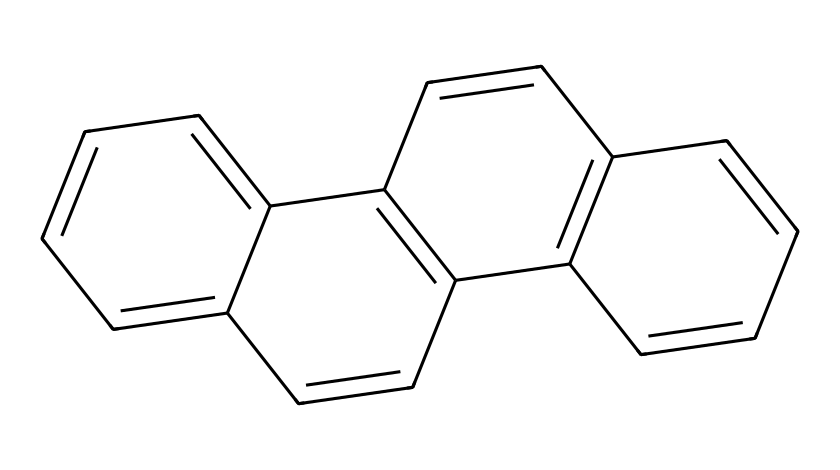What is the name of this chemical? The SMILES representation corresponds to a polycyclic aromatic hydrocarbon known as chrysene, which is characterized by its fused ring structure.
Answer: chrysene How many carbon atoms are in this molecule? By analyzing the structure represented in the SMILES, we can count a total of 18 carbon atoms in the fused ring systems.
Answer: 18 How many hydrogen atoms does this chemical have? Each carbon in this polycyclic aromatic structure is bonded to either another carbon or a hydrogen atom. Given the rings and carbon count, there are 12 hydrogen atoms.
Answer: 12 Is this molecule considered a carcinogen? Polycyclic aromatic hydrocarbons, including chrysene, are known for their potential carcinogenic properties, due to how they interact with biological systems.
Answer: yes What type of hydrocarbons does this structure represent? The structure consists of multiple fused benzene rings, classifying it as a polycyclic aromatic hydrocarbon (PAH).
Answer: polycyclic aromatic hydrocarbon How many rings are fused together in this structure? Looking at the molecular arrangement, it is clear that there are four distinct benzene rings that are fused together in the structure.
Answer: 4 What is a common source of this chemical in everyday life? Chrysene and other PAHs often originate from combustion processes, notably in sources such as motorcycle exhaust fumes, which are common among bikers.
Answer: motorcycle exhaust 